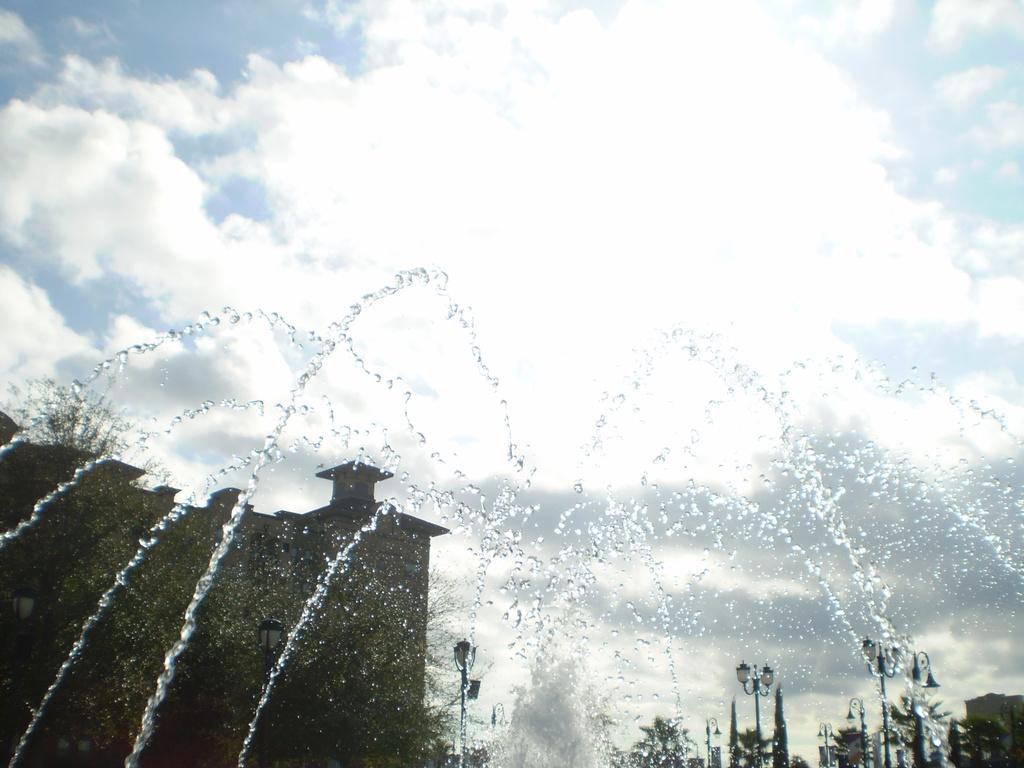What is the main feature in the image? There is a fountain in the image. What other objects can be seen in the image? There are street lights and trees in the image. What is visible at the top of the image? The sky is visible at the top of the image. What can be observed in the sky? Clouds are present in the sky. Where is the club located in the image? There is no club present in the image. How many kittens are playing with the story in the image? There are no kittens or stories present in the image. 